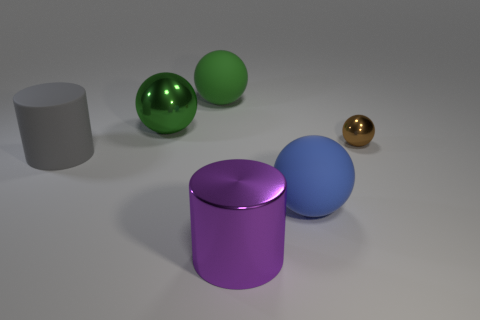How many blue objects are either spheres or tiny objects?
Your answer should be very brief. 1. How many objects are big gray metal blocks or things that are in front of the big blue rubber ball?
Give a very brief answer. 1. There is a big thing that is behind the big green metal sphere; what is its material?
Ensure brevity in your answer.  Rubber. What is the shape of the green rubber object that is the same size as the blue rubber sphere?
Your answer should be compact. Sphere. Is there a big green shiny thing that has the same shape as the big blue object?
Your response must be concise. Yes. Is the small brown object made of the same material as the big sphere that is in front of the brown thing?
Give a very brief answer. No. The large cylinder that is behind the sphere in front of the small ball is made of what material?
Provide a succinct answer. Rubber. Are there more tiny brown things that are in front of the small shiny object than small blue rubber things?
Give a very brief answer. No. Is there a small blue thing?
Provide a short and direct response. No. The metallic thing that is on the left side of the big green rubber thing is what color?
Provide a succinct answer. Green. 